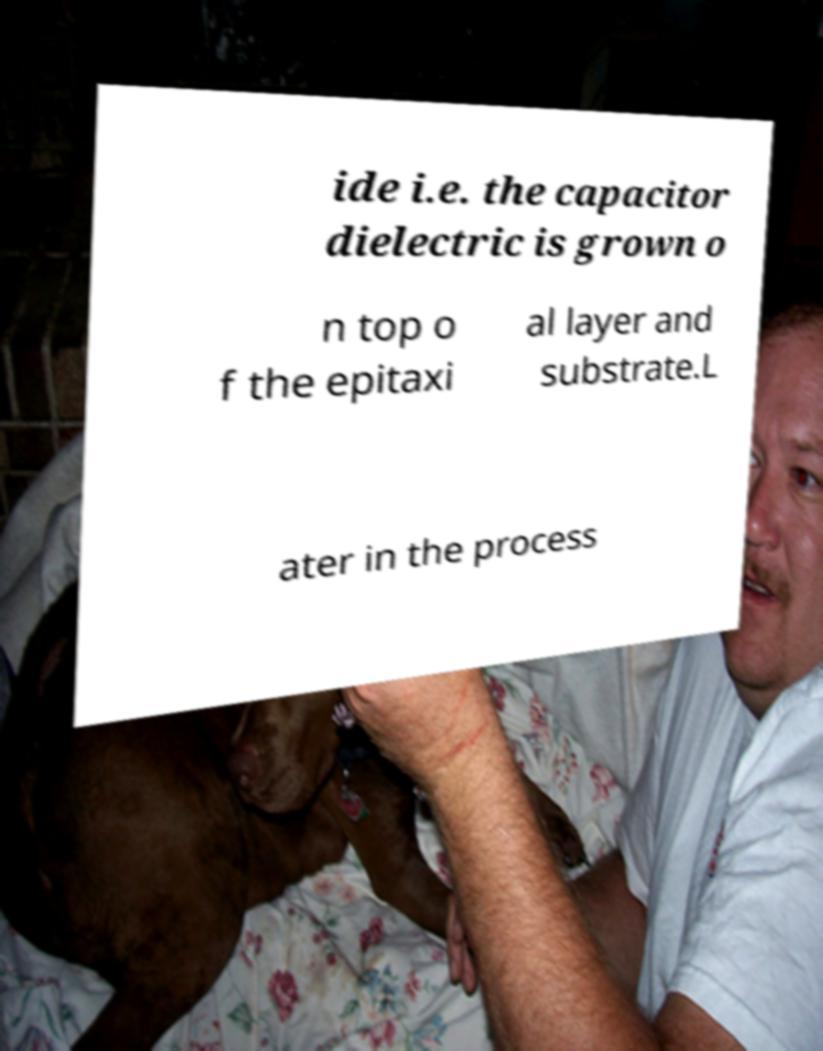There's text embedded in this image that I need extracted. Can you transcribe it verbatim? ide i.e. the capacitor dielectric is grown o n top o f the epitaxi al layer and substrate.L ater in the process 